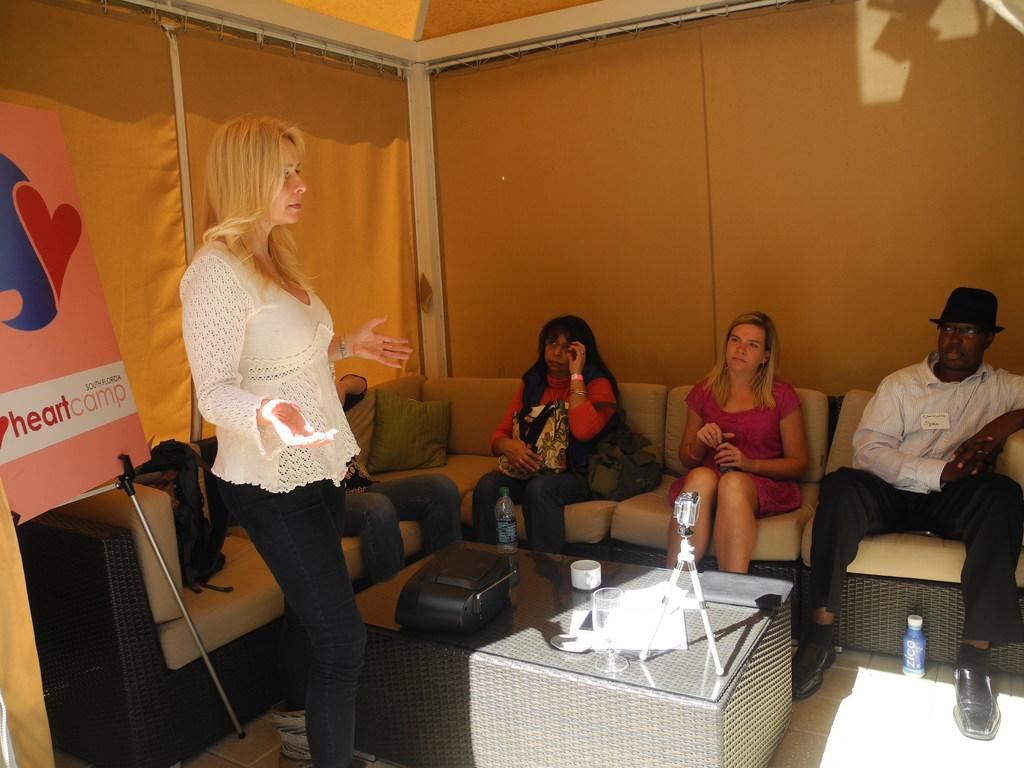Who is present in the image? There is a woman in the image. Where is the woman located in the image? The woman is standing on the right side. What is the woman doing in the image? The woman is talking. What can be seen in the background of the image? There is a sofa in the background of the image. What are the people on the sofa doing? Several people are sitting on the sofa. Where are the people sitting on the sofa located? The people are under a tent. What type of pencil is the woman holding in the image? There is no pencil present in the image; the woman is talking. Can you tell me how many people are in the cellar in the image? There is no cellar present in the image; the people are under a tent. 